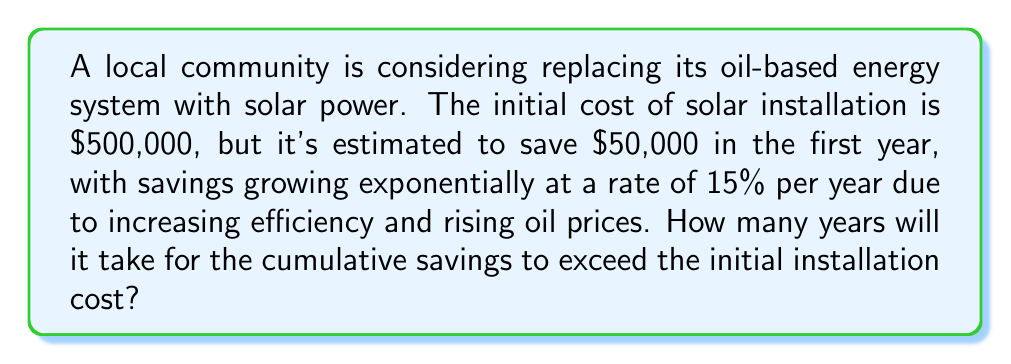Give your solution to this math problem. Let's approach this step-by-step:

1) Let $S_n$ be the savings in year $n$, and $r = 0.15$ be the growth rate.

2) The savings for each year can be modeled by the exponential function:
   $S_n = 50000 \cdot (1.15)^{n-1}$

3) We need to find the sum of these savings over $n$ years. This is given by the sum of a geometric series:
   $\sum_{k=1}^n S_k = 50000 \cdot \frac{(1.15)^n - 1}{1.15 - 1}$

4) We want to find $n$ where this sum exceeds 500000:
   $50000 \cdot \frac{(1.15)^n - 1}{0.15} > 500000$

5) Simplifying:
   $(1.15)^n - 1 > 1.5$
   $(1.15)^n > 2.5$

6) Taking logarithms of both sides:
   $n \cdot \log(1.15) > \log(2.5)$

7) Solving for $n$:
   $n > \frac{\log(2.5)}{\log(1.15)} \approx 6.43$

8) Since $n$ must be a whole number of years, we round up to 7.

Therefore, it will take 7 years for the cumulative savings to exceed the initial installation cost.
Answer: 7 years 